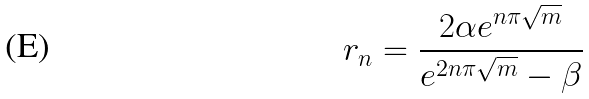Convert formula to latex. <formula><loc_0><loc_0><loc_500><loc_500>r _ { n } = \frac { 2 \alpha e ^ { n \pi \sqrt { m } } } { e ^ { 2 n \pi \sqrt { m } } - \beta }</formula> 